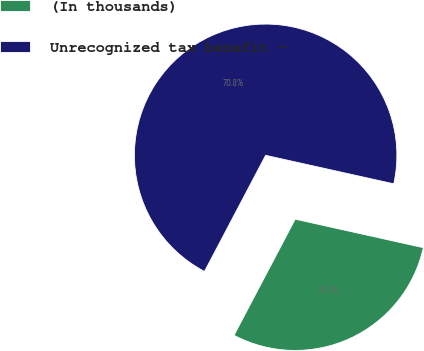Convert chart to OTSL. <chart><loc_0><loc_0><loc_500><loc_500><pie_chart><fcel>(In thousands)<fcel>Unrecognized tax benefit -<nl><fcel>29.23%<fcel>70.77%<nl></chart> 